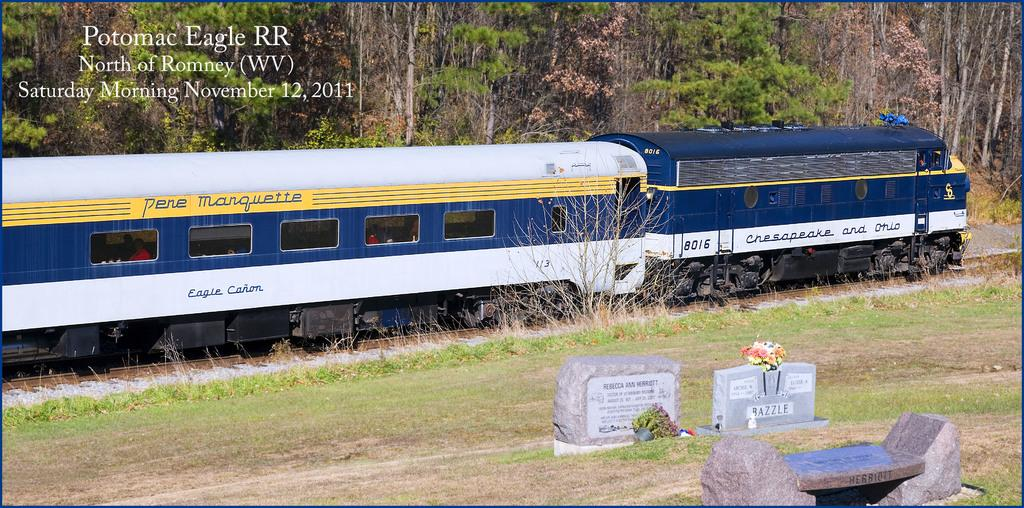What is the main subject of the image? The main subject of the image is a train. What is the train doing in the image? The train is moving on a track. What can be seen near the train in the image? There are grave stones on a side of the track. What is visible in the background of the image? There are trees behind the train. What type of parcel is being delivered by the train in the image? There is no parcel being delivered by the train in the image. What type of harmony can be observed between the train and the trees in the image? The image does not depict any harmony between the train and the trees; it simply shows a train moving on a track with trees in the background. 